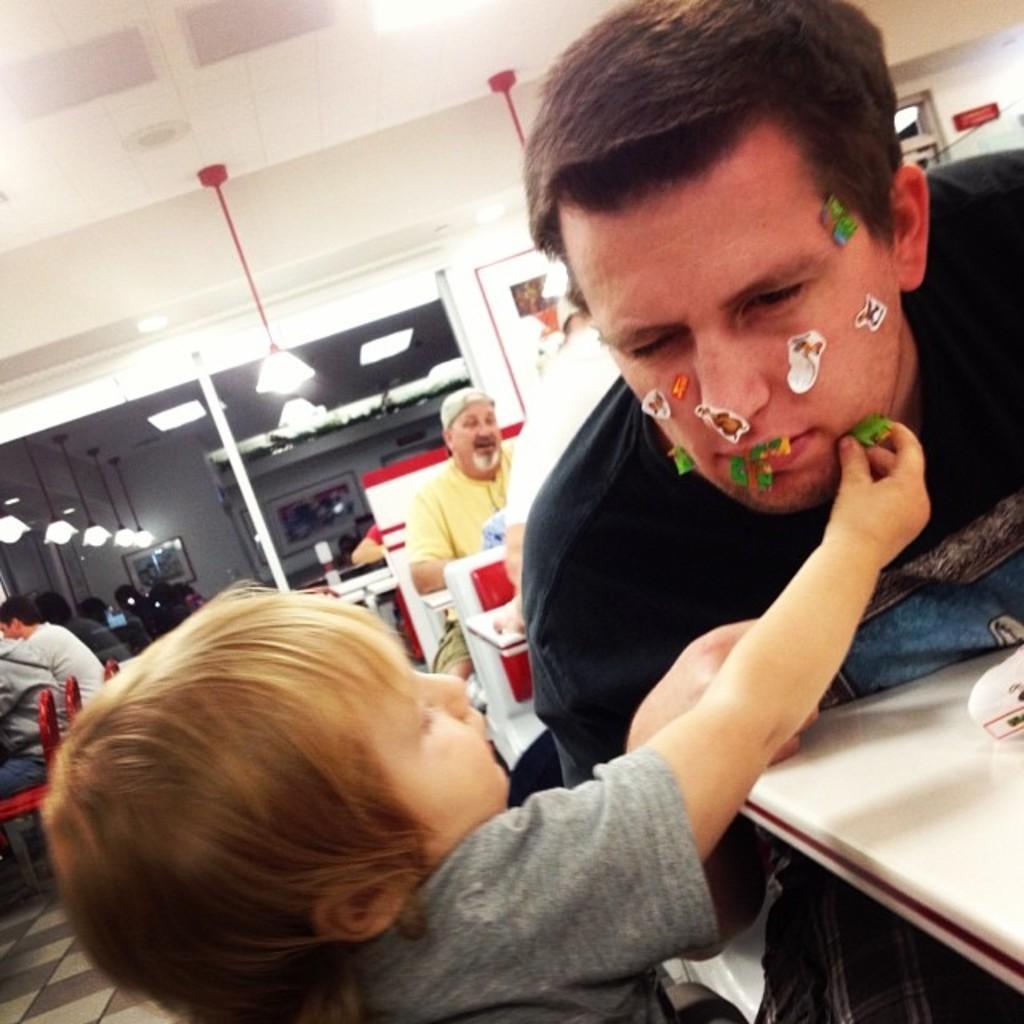Please provide a concise description of this image. In this picture we can see some people are sitting, in front we can see tables on which we can see some objects are placed, one boy is sticking stickers on a person face. 